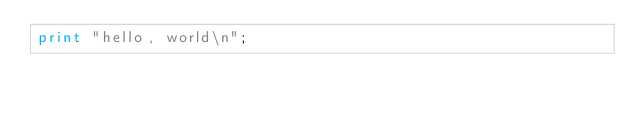Convert code to text. <code><loc_0><loc_0><loc_500><loc_500><_Perl_>print "hello, world\n";
</code> 